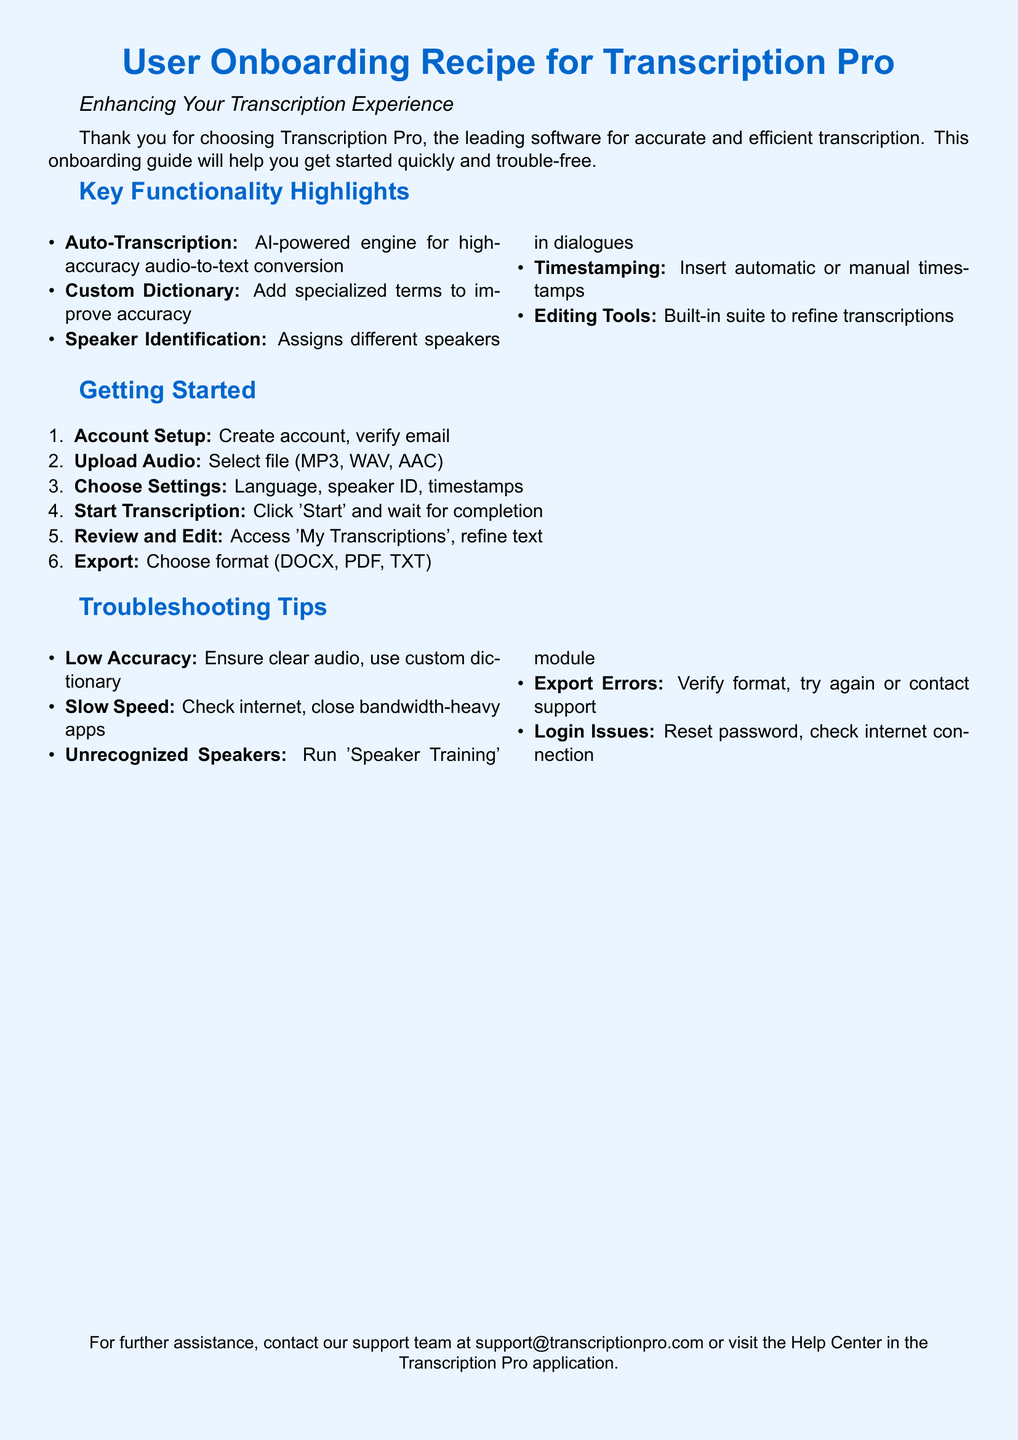What is the name of the software featured in the document? The software mentioned in the document is Transcription Pro, which is specified in the title and introduction.
Answer: Transcription Pro How many key functionality highlights are listed? The document contains five key functionality highlights included in the "Key Functionality Highlights" section.
Answer: 5 What file formats can you upload for transcription? The document explicitly states the supported audio file formats in the "Upload Audio" section, which are MP3, WAV, and AAC.
Answer: MP3, WAV, AAC What is the first step listed under "Getting Started"? The first step outlined in the "Getting Started" section is to create an account and verify the email as explained under that section.
Answer: Account Setup Which feature helps improve transcription accuracy with specialized terms? The feature aimed at enhancing accuracy by allowing users to add specialized terms is described as "Custom Dictionary" in the "Key Functionality Highlights".
Answer: Custom Dictionary What should you do if you experience low accuracy? The document suggests ensuring clear audio and using a custom dictionary as a solution in the "Troubleshooting Tips" section.
Answer: Ensure clear audio, use custom dictionary What does the 'Speaker Training' module help with? The 'Speaker Training' module is indicated as a solution for unrecognized speakers in the "Troubleshooting Tips" section of the document.
Answer: Unrecognized Speakers What is the email for further assistance? The document provides a specific email address for support inquiries in the closing statement, which is located at the bottom of the document.
Answer: support@transcriptionpro.com 